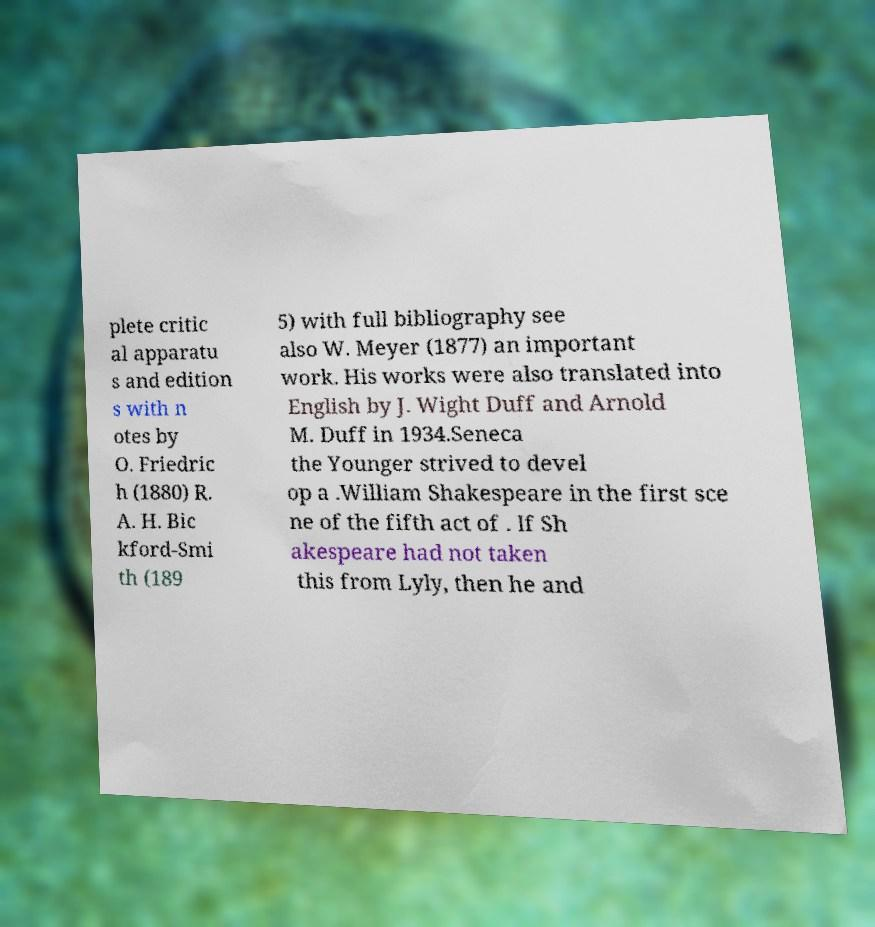Could you extract and type out the text from this image? plete critic al apparatu s and edition s with n otes by O. Friedric h (1880) R. A. H. Bic kford-Smi th (189 5) with full bibliography see also W. Meyer (1877) an important work. His works were also translated into English by J. Wight Duff and Arnold M. Duff in 1934.Seneca the Younger strived to devel op a .William Shakespeare in the first sce ne of the fifth act of . If Sh akespeare had not taken this from Lyly, then he and 